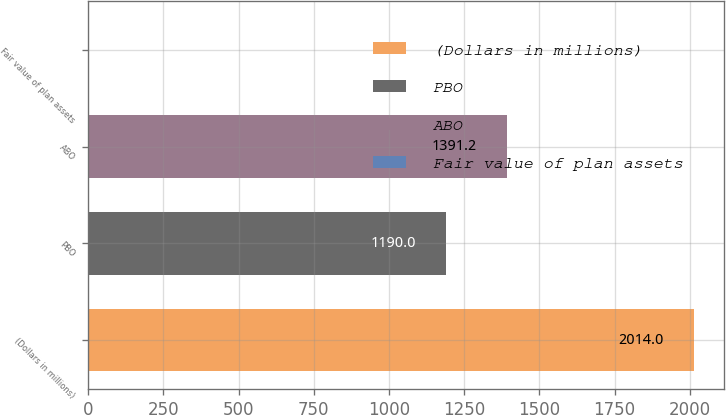<chart> <loc_0><loc_0><loc_500><loc_500><bar_chart><fcel>(Dollars in millions)<fcel>PBO<fcel>ABO<fcel>Fair value of plan assets<nl><fcel>2014<fcel>1190<fcel>1391.2<fcel>2<nl></chart> 